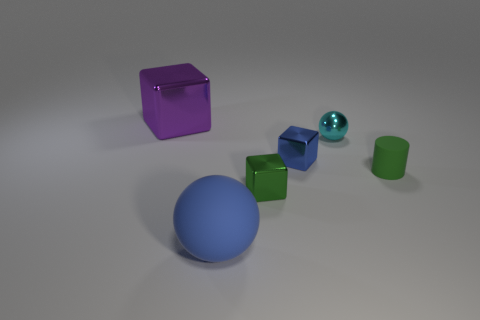What color is the matte thing that is behind the big blue sphere?
Provide a short and direct response. Green. Is the cyan thing made of the same material as the object on the left side of the big blue rubber ball?
Offer a terse response. Yes. What is the cyan sphere made of?
Provide a succinct answer. Metal. The small object that is made of the same material as the big blue thing is what shape?
Offer a very short reply. Cylinder. How many other objects are the same shape as the blue metal object?
Your answer should be very brief. 2. How many matte cylinders are behind the small sphere?
Give a very brief answer. 0. Does the block on the left side of the blue rubber object have the same size as the metal object in front of the cylinder?
Provide a short and direct response. No. What number of other objects are the same size as the green rubber thing?
Make the answer very short. 3. There is a green thing in front of the rubber thing to the right of the rubber thing to the left of the green shiny cube; what is its material?
Your answer should be very brief. Metal. Are there an equal number of metallic objects and small blue shiny things?
Your answer should be very brief. No. 